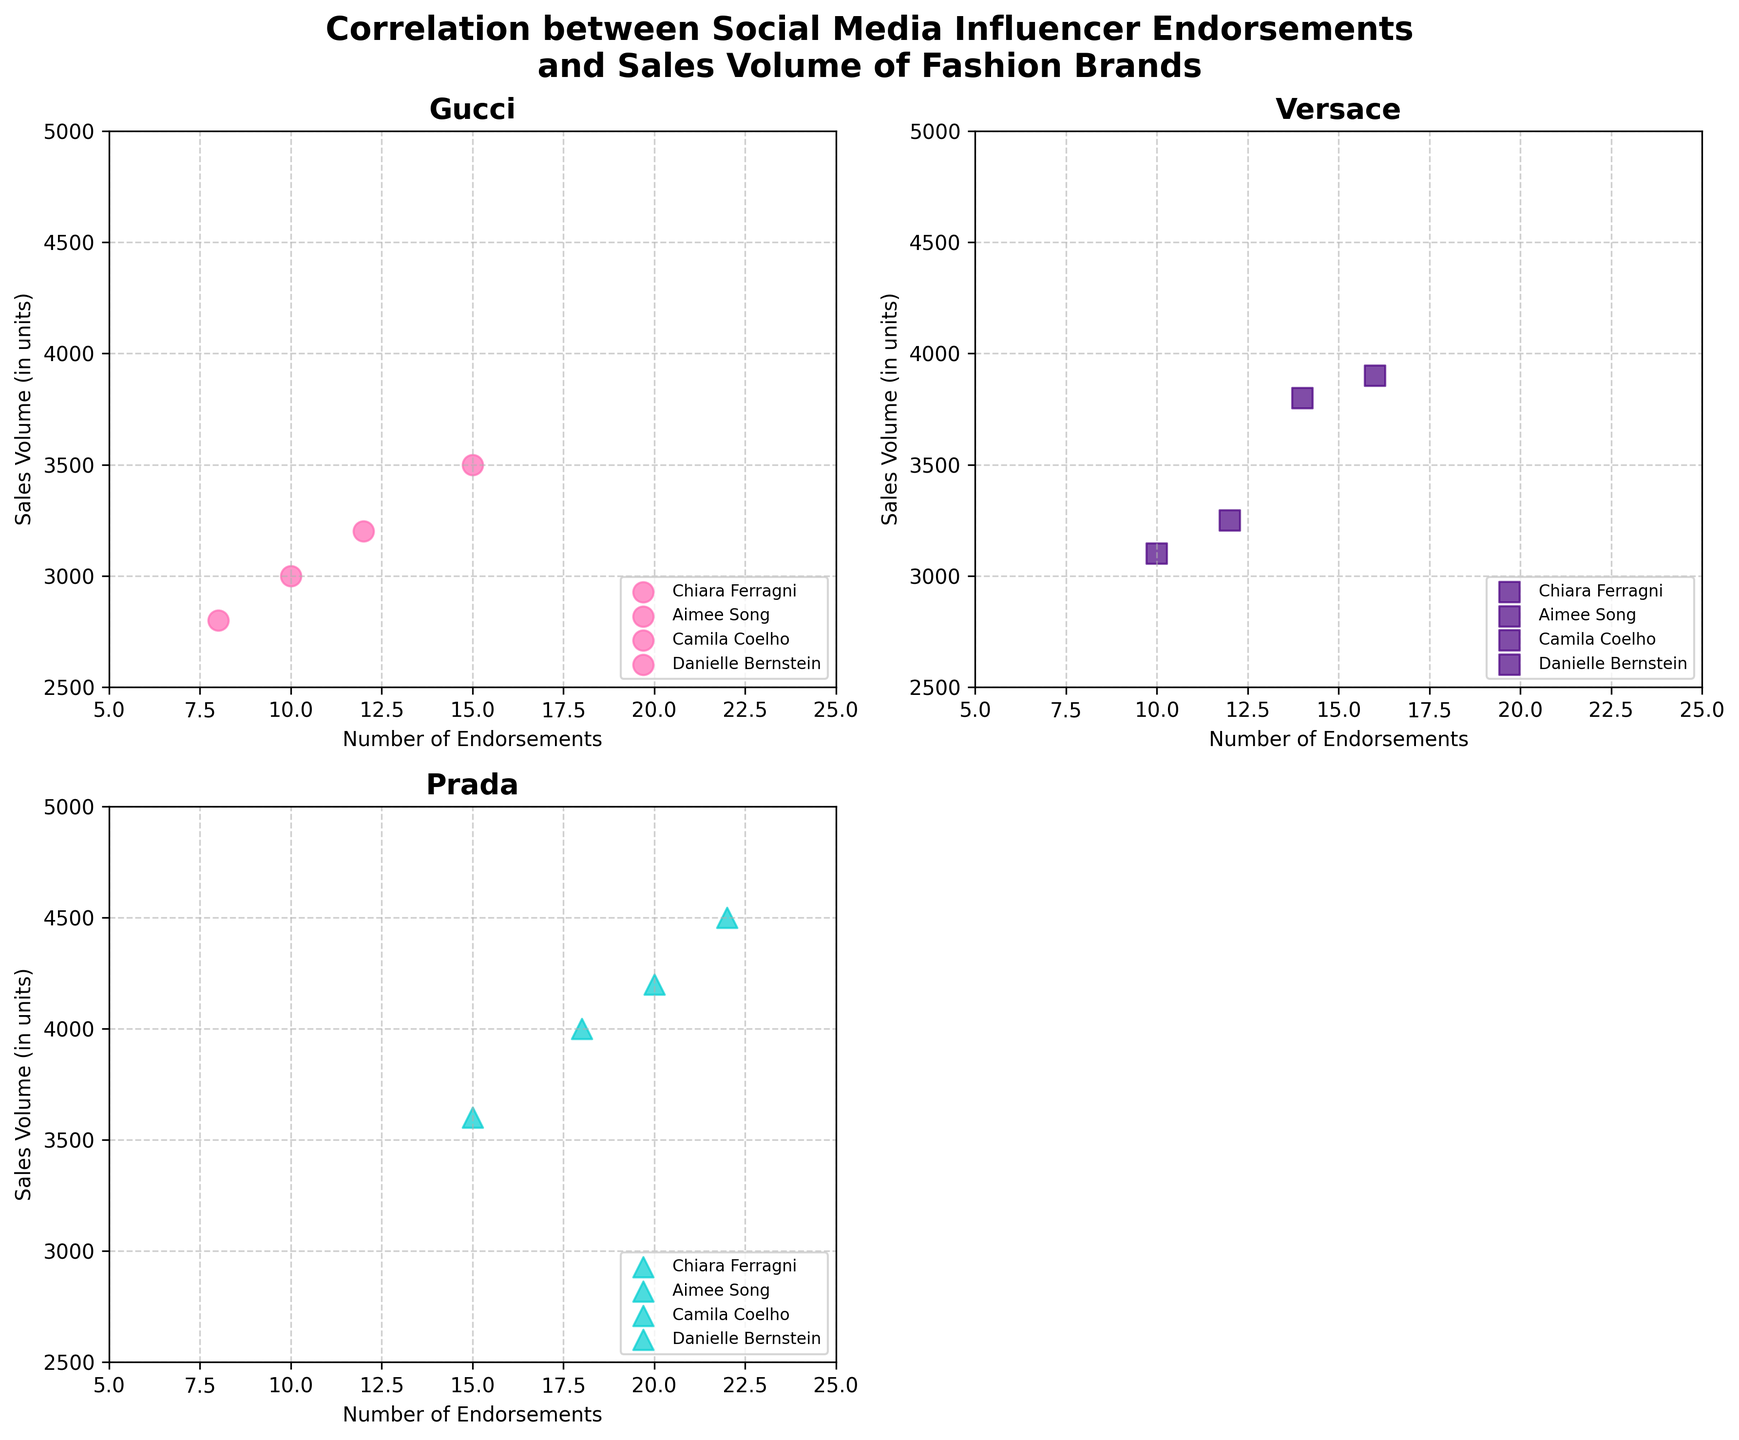what's the title of the plot? The title is at the top of the plot and provides a general description of what the plot represents. It reads, "Correlation between Social Media Influencer Endorsements and Sales Volume of Fashion Brands".
Answer: Correlation between Social Media Influencer Endorsements and Sales Volume of Fashion Brands how many brands are represented in the plot? Each subplot focuses on one brand, and there are three subplots dedicated to specific brands. Therefore, there are three brands represented.
Answer: 3 who is the influencer with the most endorsements for Versace? By examining the number of endorsements on the Versace subplot, Danielle Bernstein has the highest number at 16.
Answer: Danielle Bernstein which influencer has the highest sales volume for Gucci? In the Gucci subplot, Danielle Bernstein has the highest sales volume of 3200 units.
Answer: Danielle Bernstein how many data points are there in the subplot for Prada? In the subplot for Prada, there are six data points corresponding to the three influencers, with each having a distinct number of endorsements and sales volumes.
Answer: 6 what's the total sales volume for Camila Coelho for all brands? By checking all subplots for Camila Coelho, sum the sales volumes: Gucci (2800) + Versace (3100) + Prada (3600) = 9500 units.
Answer: 9500 units which brand shows the highest maximum sales volume among all influencers? By reviewing all subplots, the highest sales volume is for Prada with 4500 units by Danielle Bernstein.
Answer: Prada are there any subplots where influencer endorsements and sales volume show a clear positive correlation? Observing the plots, Prada shows a clear positive correlation for all influencers, where more endorsements generally lead to higher sales volumes.
Answer: Prada compare the sales volume of Aimee Song for Versace with that of Chiara Ferragni for Gucci. Which is higher? For Aimee Song: Versace's sales volume is 3800 units. For Chiara Ferragni: Gucci's sales volume is 3500 units. Therefore, Aimee Song's sales volume for Versace is higher.
Answer: Aimee Song what is the range of number of endorsements used on the x-axis? The x-axis for each subplot shows endorsements ranging from a minimum of 5 to a maximum of 25 endorsements, accommodating all data points.
Answer: 5 to 25 